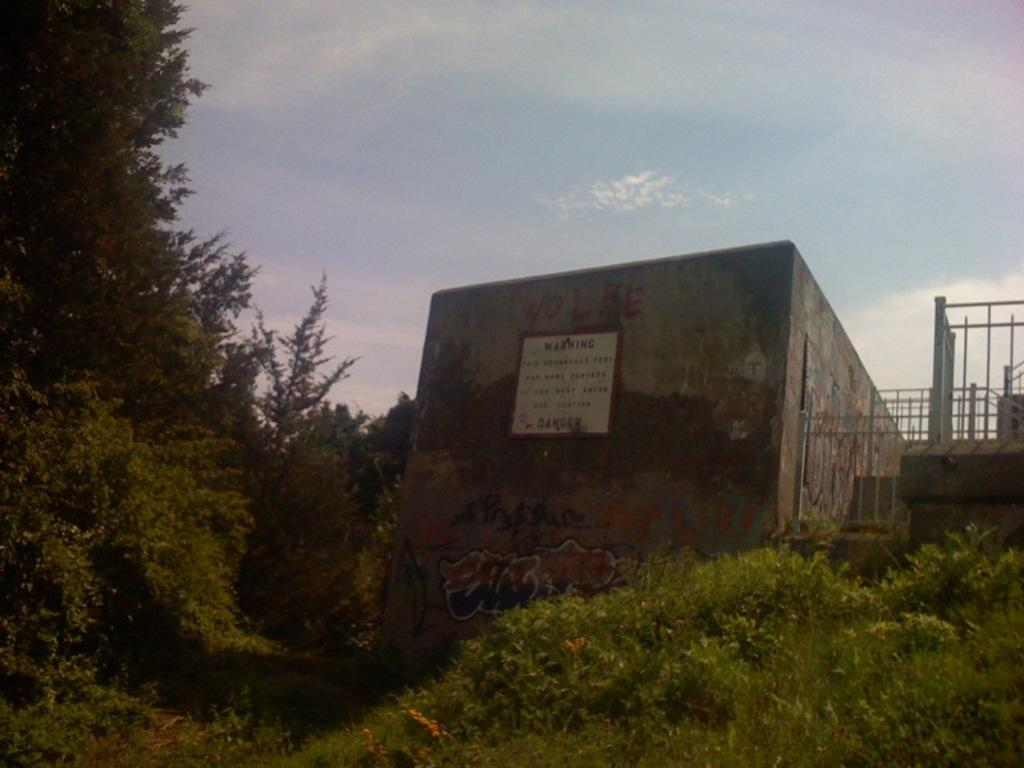What structure is located on the right side of the image? There is a building on the right side of the image. What type of vegetation can be seen in the image? There are plants and trees in the image. What is the condition of the sky in the image? The sky is clear in the image. What type of decision can be seen being made on the farm in the image? There is no farm or decision-making process depicted in the image. What type of oven is visible in the image? There is no oven present in the image. 